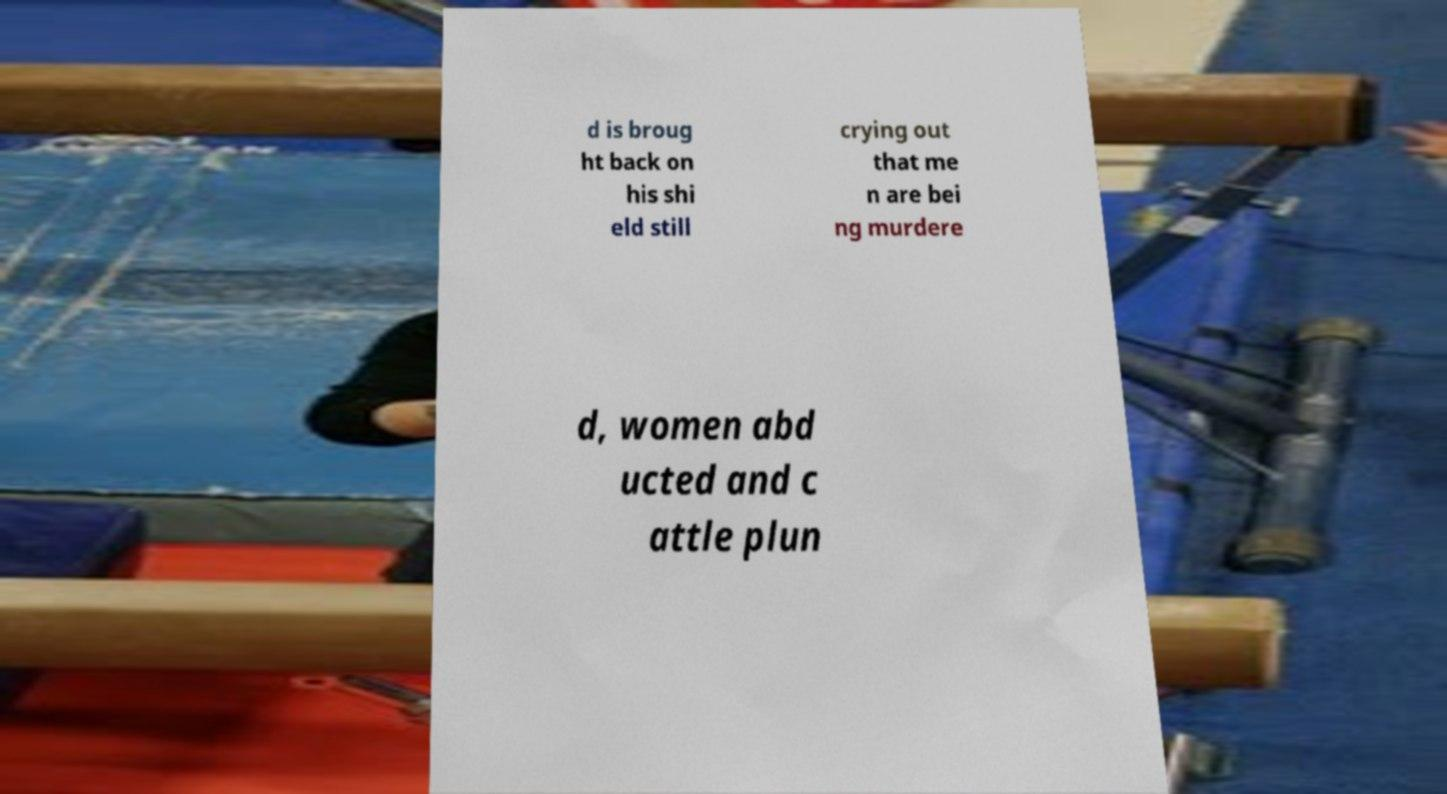Could you extract and type out the text from this image? d is broug ht back on his shi eld still crying out that me n are bei ng murdere d, women abd ucted and c attle plun 